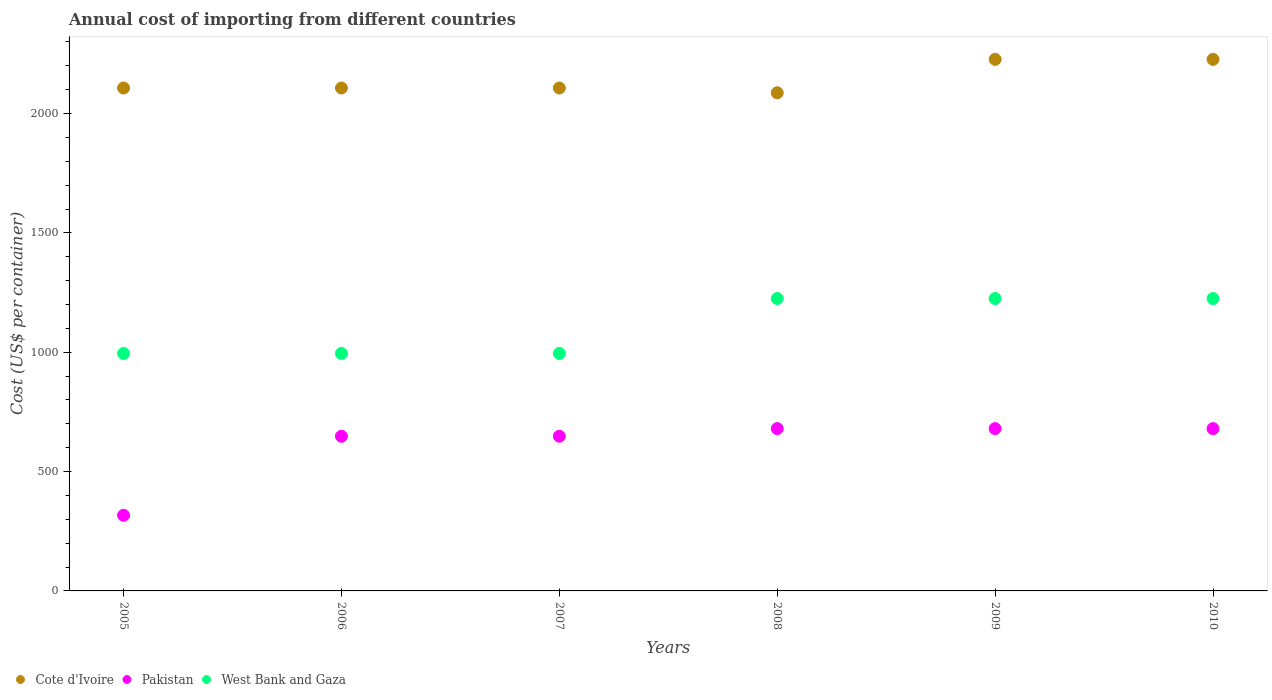How many different coloured dotlines are there?
Offer a very short reply. 3. Is the number of dotlines equal to the number of legend labels?
Your answer should be compact. Yes. What is the total annual cost of importing in Pakistan in 2009?
Offer a terse response. 680. Across all years, what is the maximum total annual cost of importing in Pakistan?
Your answer should be very brief. 680. Across all years, what is the minimum total annual cost of importing in Cote d'Ivoire?
Ensure brevity in your answer.  2087. In which year was the total annual cost of importing in Cote d'Ivoire minimum?
Offer a very short reply. 2008. What is the total total annual cost of importing in Cote d'Ivoire in the graph?
Offer a terse response. 1.29e+04. What is the difference between the total annual cost of importing in Cote d'Ivoire in 2005 and that in 2010?
Your response must be concise. -120. What is the difference between the total annual cost of importing in West Bank and Gaza in 2009 and the total annual cost of importing in Pakistan in 2010?
Offer a very short reply. 545. What is the average total annual cost of importing in Cote d'Ivoire per year?
Provide a short and direct response. 2143.67. In the year 2009, what is the difference between the total annual cost of importing in Cote d'Ivoire and total annual cost of importing in West Bank and Gaza?
Keep it short and to the point. 1002. In how many years, is the total annual cost of importing in Pakistan greater than 1700 US$?
Give a very brief answer. 0. What is the ratio of the total annual cost of importing in Pakistan in 2006 to that in 2010?
Your response must be concise. 0.95. What is the difference between the highest and the second highest total annual cost of importing in Cote d'Ivoire?
Keep it short and to the point. 0. What is the difference between the highest and the lowest total annual cost of importing in West Bank and Gaza?
Your answer should be compact. 230. In how many years, is the total annual cost of importing in Pakistan greater than the average total annual cost of importing in Pakistan taken over all years?
Your answer should be compact. 5. Is the sum of the total annual cost of importing in West Bank and Gaza in 2005 and 2008 greater than the maximum total annual cost of importing in Cote d'Ivoire across all years?
Provide a short and direct response. No. Is it the case that in every year, the sum of the total annual cost of importing in Pakistan and total annual cost of importing in Cote d'Ivoire  is greater than the total annual cost of importing in West Bank and Gaza?
Offer a terse response. Yes. Is the total annual cost of importing in Pakistan strictly greater than the total annual cost of importing in Cote d'Ivoire over the years?
Make the answer very short. No. Is the total annual cost of importing in West Bank and Gaza strictly less than the total annual cost of importing in Cote d'Ivoire over the years?
Your answer should be compact. Yes. How many dotlines are there?
Your answer should be very brief. 3. How many years are there in the graph?
Offer a very short reply. 6. Are the values on the major ticks of Y-axis written in scientific E-notation?
Your answer should be compact. No. Does the graph contain any zero values?
Your answer should be very brief. No. Where does the legend appear in the graph?
Provide a short and direct response. Bottom left. How are the legend labels stacked?
Your answer should be very brief. Horizontal. What is the title of the graph?
Your answer should be very brief. Annual cost of importing from different countries. Does "Croatia" appear as one of the legend labels in the graph?
Keep it short and to the point. No. What is the label or title of the Y-axis?
Make the answer very short. Cost (US$ per container). What is the Cost (US$ per container) of Cote d'Ivoire in 2005?
Your answer should be very brief. 2107. What is the Cost (US$ per container) in Pakistan in 2005?
Offer a very short reply. 317. What is the Cost (US$ per container) of West Bank and Gaza in 2005?
Make the answer very short. 995. What is the Cost (US$ per container) of Cote d'Ivoire in 2006?
Your answer should be compact. 2107. What is the Cost (US$ per container) in Pakistan in 2006?
Your response must be concise. 648. What is the Cost (US$ per container) of West Bank and Gaza in 2006?
Make the answer very short. 995. What is the Cost (US$ per container) of Cote d'Ivoire in 2007?
Your response must be concise. 2107. What is the Cost (US$ per container) of Pakistan in 2007?
Keep it short and to the point. 648. What is the Cost (US$ per container) in West Bank and Gaza in 2007?
Your answer should be compact. 995. What is the Cost (US$ per container) of Cote d'Ivoire in 2008?
Your response must be concise. 2087. What is the Cost (US$ per container) of Pakistan in 2008?
Keep it short and to the point. 680. What is the Cost (US$ per container) in West Bank and Gaza in 2008?
Make the answer very short. 1225. What is the Cost (US$ per container) in Cote d'Ivoire in 2009?
Make the answer very short. 2227. What is the Cost (US$ per container) in Pakistan in 2009?
Offer a very short reply. 680. What is the Cost (US$ per container) of West Bank and Gaza in 2009?
Offer a terse response. 1225. What is the Cost (US$ per container) of Cote d'Ivoire in 2010?
Your response must be concise. 2227. What is the Cost (US$ per container) in Pakistan in 2010?
Provide a short and direct response. 680. What is the Cost (US$ per container) of West Bank and Gaza in 2010?
Provide a short and direct response. 1225. Across all years, what is the maximum Cost (US$ per container) in Cote d'Ivoire?
Your answer should be very brief. 2227. Across all years, what is the maximum Cost (US$ per container) of Pakistan?
Give a very brief answer. 680. Across all years, what is the maximum Cost (US$ per container) of West Bank and Gaza?
Provide a short and direct response. 1225. Across all years, what is the minimum Cost (US$ per container) of Cote d'Ivoire?
Your response must be concise. 2087. Across all years, what is the minimum Cost (US$ per container) of Pakistan?
Your answer should be compact. 317. Across all years, what is the minimum Cost (US$ per container) in West Bank and Gaza?
Keep it short and to the point. 995. What is the total Cost (US$ per container) of Cote d'Ivoire in the graph?
Keep it short and to the point. 1.29e+04. What is the total Cost (US$ per container) in Pakistan in the graph?
Ensure brevity in your answer.  3653. What is the total Cost (US$ per container) of West Bank and Gaza in the graph?
Offer a very short reply. 6660. What is the difference between the Cost (US$ per container) of Pakistan in 2005 and that in 2006?
Offer a very short reply. -331. What is the difference between the Cost (US$ per container) of West Bank and Gaza in 2005 and that in 2006?
Make the answer very short. 0. What is the difference between the Cost (US$ per container) of Cote d'Ivoire in 2005 and that in 2007?
Offer a terse response. 0. What is the difference between the Cost (US$ per container) of Pakistan in 2005 and that in 2007?
Provide a succinct answer. -331. What is the difference between the Cost (US$ per container) of Cote d'Ivoire in 2005 and that in 2008?
Your answer should be compact. 20. What is the difference between the Cost (US$ per container) of Pakistan in 2005 and that in 2008?
Make the answer very short. -363. What is the difference between the Cost (US$ per container) of West Bank and Gaza in 2005 and that in 2008?
Ensure brevity in your answer.  -230. What is the difference between the Cost (US$ per container) in Cote d'Ivoire in 2005 and that in 2009?
Ensure brevity in your answer.  -120. What is the difference between the Cost (US$ per container) in Pakistan in 2005 and that in 2009?
Ensure brevity in your answer.  -363. What is the difference between the Cost (US$ per container) in West Bank and Gaza in 2005 and that in 2009?
Offer a very short reply. -230. What is the difference between the Cost (US$ per container) of Cote d'Ivoire in 2005 and that in 2010?
Provide a succinct answer. -120. What is the difference between the Cost (US$ per container) in Pakistan in 2005 and that in 2010?
Offer a terse response. -363. What is the difference between the Cost (US$ per container) of West Bank and Gaza in 2005 and that in 2010?
Give a very brief answer. -230. What is the difference between the Cost (US$ per container) of Pakistan in 2006 and that in 2008?
Provide a succinct answer. -32. What is the difference between the Cost (US$ per container) in West Bank and Gaza in 2006 and that in 2008?
Provide a succinct answer. -230. What is the difference between the Cost (US$ per container) of Cote d'Ivoire in 2006 and that in 2009?
Make the answer very short. -120. What is the difference between the Cost (US$ per container) in Pakistan in 2006 and that in 2009?
Your answer should be very brief. -32. What is the difference between the Cost (US$ per container) in West Bank and Gaza in 2006 and that in 2009?
Provide a succinct answer. -230. What is the difference between the Cost (US$ per container) of Cote d'Ivoire in 2006 and that in 2010?
Your response must be concise. -120. What is the difference between the Cost (US$ per container) in Pakistan in 2006 and that in 2010?
Ensure brevity in your answer.  -32. What is the difference between the Cost (US$ per container) of West Bank and Gaza in 2006 and that in 2010?
Give a very brief answer. -230. What is the difference between the Cost (US$ per container) of Pakistan in 2007 and that in 2008?
Give a very brief answer. -32. What is the difference between the Cost (US$ per container) in West Bank and Gaza in 2007 and that in 2008?
Provide a short and direct response. -230. What is the difference between the Cost (US$ per container) in Cote d'Ivoire in 2007 and that in 2009?
Give a very brief answer. -120. What is the difference between the Cost (US$ per container) of Pakistan in 2007 and that in 2009?
Your response must be concise. -32. What is the difference between the Cost (US$ per container) in West Bank and Gaza in 2007 and that in 2009?
Your answer should be compact. -230. What is the difference between the Cost (US$ per container) in Cote d'Ivoire in 2007 and that in 2010?
Provide a succinct answer. -120. What is the difference between the Cost (US$ per container) in Pakistan in 2007 and that in 2010?
Give a very brief answer. -32. What is the difference between the Cost (US$ per container) in West Bank and Gaza in 2007 and that in 2010?
Offer a terse response. -230. What is the difference between the Cost (US$ per container) in Cote d'Ivoire in 2008 and that in 2009?
Your response must be concise. -140. What is the difference between the Cost (US$ per container) in West Bank and Gaza in 2008 and that in 2009?
Ensure brevity in your answer.  0. What is the difference between the Cost (US$ per container) in Cote d'Ivoire in 2008 and that in 2010?
Keep it short and to the point. -140. What is the difference between the Cost (US$ per container) of West Bank and Gaza in 2008 and that in 2010?
Your answer should be very brief. 0. What is the difference between the Cost (US$ per container) of Cote d'Ivoire in 2009 and that in 2010?
Offer a terse response. 0. What is the difference between the Cost (US$ per container) of Pakistan in 2009 and that in 2010?
Your response must be concise. 0. What is the difference between the Cost (US$ per container) of West Bank and Gaza in 2009 and that in 2010?
Make the answer very short. 0. What is the difference between the Cost (US$ per container) in Cote d'Ivoire in 2005 and the Cost (US$ per container) in Pakistan in 2006?
Your answer should be very brief. 1459. What is the difference between the Cost (US$ per container) of Cote d'Ivoire in 2005 and the Cost (US$ per container) of West Bank and Gaza in 2006?
Ensure brevity in your answer.  1112. What is the difference between the Cost (US$ per container) in Pakistan in 2005 and the Cost (US$ per container) in West Bank and Gaza in 2006?
Ensure brevity in your answer.  -678. What is the difference between the Cost (US$ per container) in Cote d'Ivoire in 2005 and the Cost (US$ per container) in Pakistan in 2007?
Your answer should be very brief. 1459. What is the difference between the Cost (US$ per container) in Cote d'Ivoire in 2005 and the Cost (US$ per container) in West Bank and Gaza in 2007?
Provide a succinct answer. 1112. What is the difference between the Cost (US$ per container) in Pakistan in 2005 and the Cost (US$ per container) in West Bank and Gaza in 2007?
Your answer should be compact. -678. What is the difference between the Cost (US$ per container) in Cote d'Ivoire in 2005 and the Cost (US$ per container) in Pakistan in 2008?
Your answer should be compact. 1427. What is the difference between the Cost (US$ per container) of Cote d'Ivoire in 2005 and the Cost (US$ per container) of West Bank and Gaza in 2008?
Ensure brevity in your answer.  882. What is the difference between the Cost (US$ per container) in Pakistan in 2005 and the Cost (US$ per container) in West Bank and Gaza in 2008?
Provide a short and direct response. -908. What is the difference between the Cost (US$ per container) in Cote d'Ivoire in 2005 and the Cost (US$ per container) in Pakistan in 2009?
Offer a terse response. 1427. What is the difference between the Cost (US$ per container) in Cote d'Ivoire in 2005 and the Cost (US$ per container) in West Bank and Gaza in 2009?
Offer a terse response. 882. What is the difference between the Cost (US$ per container) of Pakistan in 2005 and the Cost (US$ per container) of West Bank and Gaza in 2009?
Give a very brief answer. -908. What is the difference between the Cost (US$ per container) in Cote d'Ivoire in 2005 and the Cost (US$ per container) in Pakistan in 2010?
Keep it short and to the point. 1427. What is the difference between the Cost (US$ per container) of Cote d'Ivoire in 2005 and the Cost (US$ per container) of West Bank and Gaza in 2010?
Your answer should be very brief. 882. What is the difference between the Cost (US$ per container) of Pakistan in 2005 and the Cost (US$ per container) of West Bank and Gaza in 2010?
Your answer should be compact. -908. What is the difference between the Cost (US$ per container) in Cote d'Ivoire in 2006 and the Cost (US$ per container) in Pakistan in 2007?
Offer a terse response. 1459. What is the difference between the Cost (US$ per container) of Cote d'Ivoire in 2006 and the Cost (US$ per container) of West Bank and Gaza in 2007?
Give a very brief answer. 1112. What is the difference between the Cost (US$ per container) in Pakistan in 2006 and the Cost (US$ per container) in West Bank and Gaza in 2007?
Offer a terse response. -347. What is the difference between the Cost (US$ per container) in Cote d'Ivoire in 2006 and the Cost (US$ per container) in Pakistan in 2008?
Offer a very short reply. 1427. What is the difference between the Cost (US$ per container) in Cote d'Ivoire in 2006 and the Cost (US$ per container) in West Bank and Gaza in 2008?
Make the answer very short. 882. What is the difference between the Cost (US$ per container) of Pakistan in 2006 and the Cost (US$ per container) of West Bank and Gaza in 2008?
Give a very brief answer. -577. What is the difference between the Cost (US$ per container) of Cote d'Ivoire in 2006 and the Cost (US$ per container) of Pakistan in 2009?
Offer a terse response. 1427. What is the difference between the Cost (US$ per container) of Cote d'Ivoire in 2006 and the Cost (US$ per container) of West Bank and Gaza in 2009?
Give a very brief answer. 882. What is the difference between the Cost (US$ per container) of Pakistan in 2006 and the Cost (US$ per container) of West Bank and Gaza in 2009?
Provide a succinct answer. -577. What is the difference between the Cost (US$ per container) in Cote d'Ivoire in 2006 and the Cost (US$ per container) in Pakistan in 2010?
Your answer should be compact. 1427. What is the difference between the Cost (US$ per container) of Cote d'Ivoire in 2006 and the Cost (US$ per container) of West Bank and Gaza in 2010?
Offer a terse response. 882. What is the difference between the Cost (US$ per container) of Pakistan in 2006 and the Cost (US$ per container) of West Bank and Gaza in 2010?
Offer a very short reply. -577. What is the difference between the Cost (US$ per container) in Cote d'Ivoire in 2007 and the Cost (US$ per container) in Pakistan in 2008?
Your answer should be very brief. 1427. What is the difference between the Cost (US$ per container) of Cote d'Ivoire in 2007 and the Cost (US$ per container) of West Bank and Gaza in 2008?
Keep it short and to the point. 882. What is the difference between the Cost (US$ per container) in Pakistan in 2007 and the Cost (US$ per container) in West Bank and Gaza in 2008?
Your response must be concise. -577. What is the difference between the Cost (US$ per container) of Cote d'Ivoire in 2007 and the Cost (US$ per container) of Pakistan in 2009?
Ensure brevity in your answer.  1427. What is the difference between the Cost (US$ per container) of Cote d'Ivoire in 2007 and the Cost (US$ per container) of West Bank and Gaza in 2009?
Your answer should be compact. 882. What is the difference between the Cost (US$ per container) of Pakistan in 2007 and the Cost (US$ per container) of West Bank and Gaza in 2009?
Your response must be concise. -577. What is the difference between the Cost (US$ per container) in Cote d'Ivoire in 2007 and the Cost (US$ per container) in Pakistan in 2010?
Provide a short and direct response. 1427. What is the difference between the Cost (US$ per container) in Cote d'Ivoire in 2007 and the Cost (US$ per container) in West Bank and Gaza in 2010?
Make the answer very short. 882. What is the difference between the Cost (US$ per container) in Pakistan in 2007 and the Cost (US$ per container) in West Bank and Gaza in 2010?
Offer a terse response. -577. What is the difference between the Cost (US$ per container) of Cote d'Ivoire in 2008 and the Cost (US$ per container) of Pakistan in 2009?
Give a very brief answer. 1407. What is the difference between the Cost (US$ per container) of Cote d'Ivoire in 2008 and the Cost (US$ per container) of West Bank and Gaza in 2009?
Give a very brief answer. 862. What is the difference between the Cost (US$ per container) in Pakistan in 2008 and the Cost (US$ per container) in West Bank and Gaza in 2009?
Give a very brief answer. -545. What is the difference between the Cost (US$ per container) in Cote d'Ivoire in 2008 and the Cost (US$ per container) in Pakistan in 2010?
Offer a terse response. 1407. What is the difference between the Cost (US$ per container) of Cote d'Ivoire in 2008 and the Cost (US$ per container) of West Bank and Gaza in 2010?
Make the answer very short. 862. What is the difference between the Cost (US$ per container) of Pakistan in 2008 and the Cost (US$ per container) of West Bank and Gaza in 2010?
Ensure brevity in your answer.  -545. What is the difference between the Cost (US$ per container) in Cote d'Ivoire in 2009 and the Cost (US$ per container) in Pakistan in 2010?
Ensure brevity in your answer.  1547. What is the difference between the Cost (US$ per container) in Cote d'Ivoire in 2009 and the Cost (US$ per container) in West Bank and Gaza in 2010?
Your answer should be very brief. 1002. What is the difference between the Cost (US$ per container) of Pakistan in 2009 and the Cost (US$ per container) of West Bank and Gaza in 2010?
Offer a terse response. -545. What is the average Cost (US$ per container) in Cote d'Ivoire per year?
Your answer should be compact. 2143.67. What is the average Cost (US$ per container) of Pakistan per year?
Provide a succinct answer. 608.83. What is the average Cost (US$ per container) of West Bank and Gaza per year?
Provide a succinct answer. 1110. In the year 2005, what is the difference between the Cost (US$ per container) of Cote d'Ivoire and Cost (US$ per container) of Pakistan?
Provide a short and direct response. 1790. In the year 2005, what is the difference between the Cost (US$ per container) of Cote d'Ivoire and Cost (US$ per container) of West Bank and Gaza?
Provide a short and direct response. 1112. In the year 2005, what is the difference between the Cost (US$ per container) of Pakistan and Cost (US$ per container) of West Bank and Gaza?
Your answer should be compact. -678. In the year 2006, what is the difference between the Cost (US$ per container) of Cote d'Ivoire and Cost (US$ per container) of Pakistan?
Ensure brevity in your answer.  1459. In the year 2006, what is the difference between the Cost (US$ per container) of Cote d'Ivoire and Cost (US$ per container) of West Bank and Gaza?
Make the answer very short. 1112. In the year 2006, what is the difference between the Cost (US$ per container) of Pakistan and Cost (US$ per container) of West Bank and Gaza?
Your answer should be compact. -347. In the year 2007, what is the difference between the Cost (US$ per container) of Cote d'Ivoire and Cost (US$ per container) of Pakistan?
Your response must be concise. 1459. In the year 2007, what is the difference between the Cost (US$ per container) in Cote d'Ivoire and Cost (US$ per container) in West Bank and Gaza?
Provide a short and direct response. 1112. In the year 2007, what is the difference between the Cost (US$ per container) of Pakistan and Cost (US$ per container) of West Bank and Gaza?
Provide a short and direct response. -347. In the year 2008, what is the difference between the Cost (US$ per container) of Cote d'Ivoire and Cost (US$ per container) of Pakistan?
Offer a terse response. 1407. In the year 2008, what is the difference between the Cost (US$ per container) of Cote d'Ivoire and Cost (US$ per container) of West Bank and Gaza?
Ensure brevity in your answer.  862. In the year 2008, what is the difference between the Cost (US$ per container) of Pakistan and Cost (US$ per container) of West Bank and Gaza?
Keep it short and to the point. -545. In the year 2009, what is the difference between the Cost (US$ per container) in Cote d'Ivoire and Cost (US$ per container) in Pakistan?
Provide a succinct answer. 1547. In the year 2009, what is the difference between the Cost (US$ per container) of Cote d'Ivoire and Cost (US$ per container) of West Bank and Gaza?
Ensure brevity in your answer.  1002. In the year 2009, what is the difference between the Cost (US$ per container) of Pakistan and Cost (US$ per container) of West Bank and Gaza?
Your response must be concise. -545. In the year 2010, what is the difference between the Cost (US$ per container) of Cote d'Ivoire and Cost (US$ per container) of Pakistan?
Your answer should be compact. 1547. In the year 2010, what is the difference between the Cost (US$ per container) of Cote d'Ivoire and Cost (US$ per container) of West Bank and Gaza?
Offer a terse response. 1002. In the year 2010, what is the difference between the Cost (US$ per container) of Pakistan and Cost (US$ per container) of West Bank and Gaza?
Your response must be concise. -545. What is the ratio of the Cost (US$ per container) of Pakistan in 2005 to that in 2006?
Your answer should be compact. 0.49. What is the ratio of the Cost (US$ per container) in Pakistan in 2005 to that in 2007?
Provide a short and direct response. 0.49. What is the ratio of the Cost (US$ per container) in West Bank and Gaza in 2005 to that in 2007?
Your answer should be compact. 1. What is the ratio of the Cost (US$ per container) of Cote d'Ivoire in 2005 to that in 2008?
Your response must be concise. 1.01. What is the ratio of the Cost (US$ per container) in Pakistan in 2005 to that in 2008?
Provide a short and direct response. 0.47. What is the ratio of the Cost (US$ per container) in West Bank and Gaza in 2005 to that in 2008?
Offer a terse response. 0.81. What is the ratio of the Cost (US$ per container) in Cote d'Ivoire in 2005 to that in 2009?
Offer a terse response. 0.95. What is the ratio of the Cost (US$ per container) of Pakistan in 2005 to that in 2009?
Provide a succinct answer. 0.47. What is the ratio of the Cost (US$ per container) of West Bank and Gaza in 2005 to that in 2009?
Offer a terse response. 0.81. What is the ratio of the Cost (US$ per container) of Cote d'Ivoire in 2005 to that in 2010?
Ensure brevity in your answer.  0.95. What is the ratio of the Cost (US$ per container) in Pakistan in 2005 to that in 2010?
Offer a very short reply. 0.47. What is the ratio of the Cost (US$ per container) in West Bank and Gaza in 2005 to that in 2010?
Give a very brief answer. 0.81. What is the ratio of the Cost (US$ per container) in Pakistan in 2006 to that in 2007?
Offer a terse response. 1. What is the ratio of the Cost (US$ per container) in Cote d'Ivoire in 2006 to that in 2008?
Provide a succinct answer. 1.01. What is the ratio of the Cost (US$ per container) in Pakistan in 2006 to that in 2008?
Offer a terse response. 0.95. What is the ratio of the Cost (US$ per container) of West Bank and Gaza in 2006 to that in 2008?
Your answer should be compact. 0.81. What is the ratio of the Cost (US$ per container) in Cote d'Ivoire in 2006 to that in 2009?
Provide a succinct answer. 0.95. What is the ratio of the Cost (US$ per container) of Pakistan in 2006 to that in 2009?
Your answer should be very brief. 0.95. What is the ratio of the Cost (US$ per container) of West Bank and Gaza in 2006 to that in 2009?
Ensure brevity in your answer.  0.81. What is the ratio of the Cost (US$ per container) of Cote d'Ivoire in 2006 to that in 2010?
Make the answer very short. 0.95. What is the ratio of the Cost (US$ per container) in Pakistan in 2006 to that in 2010?
Keep it short and to the point. 0.95. What is the ratio of the Cost (US$ per container) in West Bank and Gaza in 2006 to that in 2010?
Offer a terse response. 0.81. What is the ratio of the Cost (US$ per container) in Cote d'Ivoire in 2007 to that in 2008?
Make the answer very short. 1.01. What is the ratio of the Cost (US$ per container) in Pakistan in 2007 to that in 2008?
Make the answer very short. 0.95. What is the ratio of the Cost (US$ per container) in West Bank and Gaza in 2007 to that in 2008?
Your response must be concise. 0.81. What is the ratio of the Cost (US$ per container) in Cote d'Ivoire in 2007 to that in 2009?
Ensure brevity in your answer.  0.95. What is the ratio of the Cost (US$ per container) in Pakistan in 2007 to that in 2009?
Your answer should be very brief. 0.95. What is the ratio of the Cost (US$ per container) of West Bank and Gaza in 2007 to that in 2009?
Offer a terse response. 0.81. What is the ratio of the Cost (US$ per container) in Cote d'Ivoire in 2007 to that in 2010?
Provide a short and direct response. 0.95. What is the ratio of the Cost (US$ per container) in Pakistan in 2007 to that in 2010?
Offer a terse response. 0.95. What is the ratio of the Cost (US$ per container) in West Bank and Gaza in 2007 to that in 2010?
Make the answer very short. 0.81. What is the ratio of the Cost (US$ per container) in Cote d'Ivoire in 2008 to that in 2009?
Your answer should be very brief. 0.94. What is the ratio of the Cost (US$ per container) of Cote d'Ivoire in 2008 to that in 2010?
Your response must be concise. 0.94. What is the ratio of the Cost (US$ per container) in Pakistan in 2008 to that in 2010?
Offer a very short reply. 1. What is the ratio of the Cost (US$ per container) of Pakistan in 2009 to that in 2010?
Provide a succinct answer. 1. What is the ratio of the Cost (US$ per container) of West Bank and Gaza in 2009 to that in 2010?
Keep it short and to the point. 1. What is the difference between the highest and the second highest Cost (US$ per container) of Pakistan?
Your answer should be compact. 0. What is the difference between the highest and the second highest Cost (US$ per container) in West Bank and Gaza?
Offer a terse response. 0. What is the difference between the highest and the lowest Cost (US$ per container) in Cote d'Ivoire?
Your answer should be very brief. 140. What is the difference between the highest and the lowest Cost (US$ per container) of Pakistan?
Your answer should be very brief. 363. What is the difference between the highest and the lowest Cost (US$ per container) in West Bank and Gaza?
Ensure brevity in your answer.  230. 